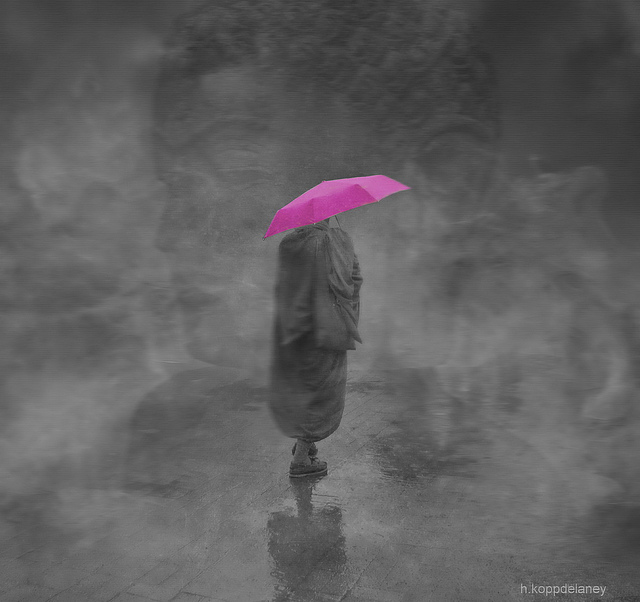What is the mood or theme conveyed by the contrast between the colorful umbrella and the grayscale background? The vibrant pink umbrella stands out against the monochrome backdrop, creating a striking contrast that conveys a feeling of hope or optimism amidst a somber or melancholic setting. It symbolizes a light of positivity or a beacon of color in the face of grayness, often suggesting an underlying theme of finding joy in the midst of adversity. What does the blurred effect surrounding the figure suggest about the setting or atmosphere? The blurred effect depicts a sense of motion or ethereal quality, implying a possible mist or rainfall that adds to the mysterious and surreal nature of the scene. It suggests that the figure might be in a transient moment, perhaps caught amidst change or the passage of time, leading to an atmosphere that is both introspective and isolating. 